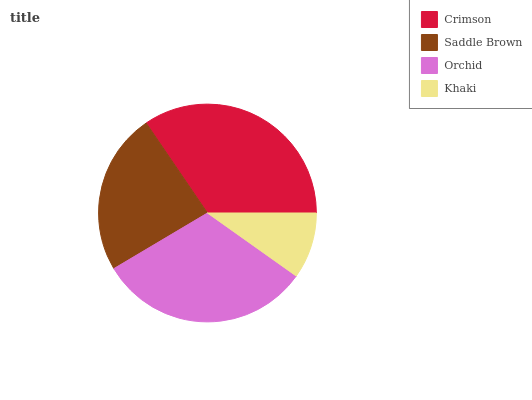Is Khaki the minimum?
Answer yes or no. Yes. Is Crimson the maximum?
Answer yes or no. Yes. Is Saddle Brown the minimum?
Answer yes or no. No. Is Saddle Brown the maximum?
Answer yes or no. No. Is Crimson greater than Saddle Brown?
Answer yes or no. Yes. Is Saddle Brown less than Crimson?
Answer yes or no. Yes. Is Saddle Brown greater than Crimson?
Answer yes or no. No. Is Crimson less than Saddle Brown?
Answer yes or no. No. Is Orchid the high median?
Answer yes or no. Yes. Is Saddle Brown the low median?
Answer yes or no. Yes. Is Saddle Brown the high median?
Answer yes or no. No. Is Orchid the low median?
Answer yes or no. No. 